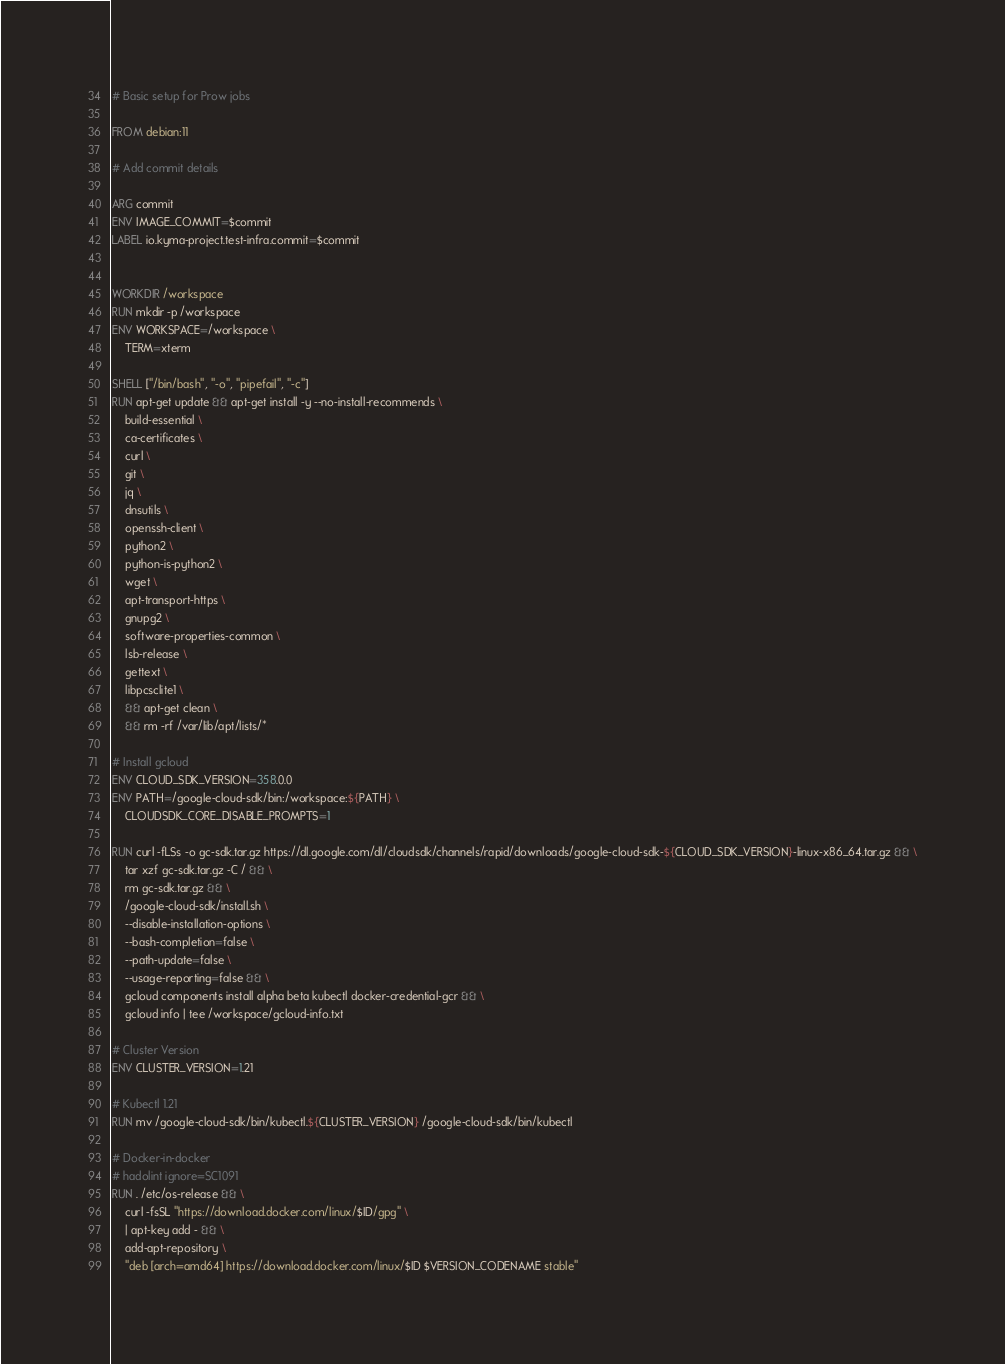<code> <loc_0><loc_0><loc_500><loc_500><_Dockerfile_># Basic setup for Prow jobs

FROM debian:11

# Add commit details

ARG commit
ENV IMAGE_COMMIT=$commit
LABEL io.kyma-project.test-infra.commit=$commit


WORKDIR /workspace
RUN mkdir -p /workspace
ENV WORKSPACE=/workspace \
    TERM=xterm

SHELL ["/bin/bash", "-o", "pipefail", "-c"]
RUN apt-get update && apt-get install -y --no-install-recommends \
    build-essential \
    ca-certificates \
    curl \
    git \
    jq \
    dnsutils \
    openssh-client \
    python2 \
    python-is-python2 \
    wget \
    apt-transport-https \
    gnupg2 \
    software-properties-common \
    lsb-release \
    gettext \
    libpcsclite1 \
    && apt-get clean \
    && rm -rf /var/lib/apt/lists/*

# Install gcloud
ENV CLOUD_SDK_VERSION=358.0.0
ENV PATH=/google-cloud-sdk/bin:/workspace:${PATH} \
    CLOUDSDK_CORE_DISABLE_PROMPTS=1

RUN curl -fLSs -o gc-sdk.tar.gz https://dl.google.com/dl/cloudsdk/channels/rapid/downloads/google-cloud-sdk-${CLOUD_SDK_VERSION}-linux-x86_64.tar.gz && \
    tar xzf gc-sdk.tar.gz -C / && \
    rm gc-sdk.tar.gz && \
    /google-cloud-sdk/install.sh \
    --disable-installation-options \
    --bash-completion=false \
    --path-update=false \
    --usage-reporting=false && \
    gcloud components install alpha beta kubectl docker-credential-gcr && \
    gcloud info | tee /workspace/gcloud-info.txt

# Cluster Version
ENV CLUSTER_VERSION=1.21

# Kubectl 1.21
RUN mv /google-cloud-sdk/bin/kubectl.${CLUSTER_VERSION} /google-cloud-sdk/bin/kubectl

# Docker-in-docker
# hadolint ignore=SC1091
RUN . /etc/os-release && \
    curl -fsSL "https://download.docker.com/linux/$ID/gpg" \
    | apt-key add - && \
    add-apt-repository \
    "deb [arch=amd64] https://download.docker.com/linux/$ID $VERSION_CODENAME stable"
</code> 